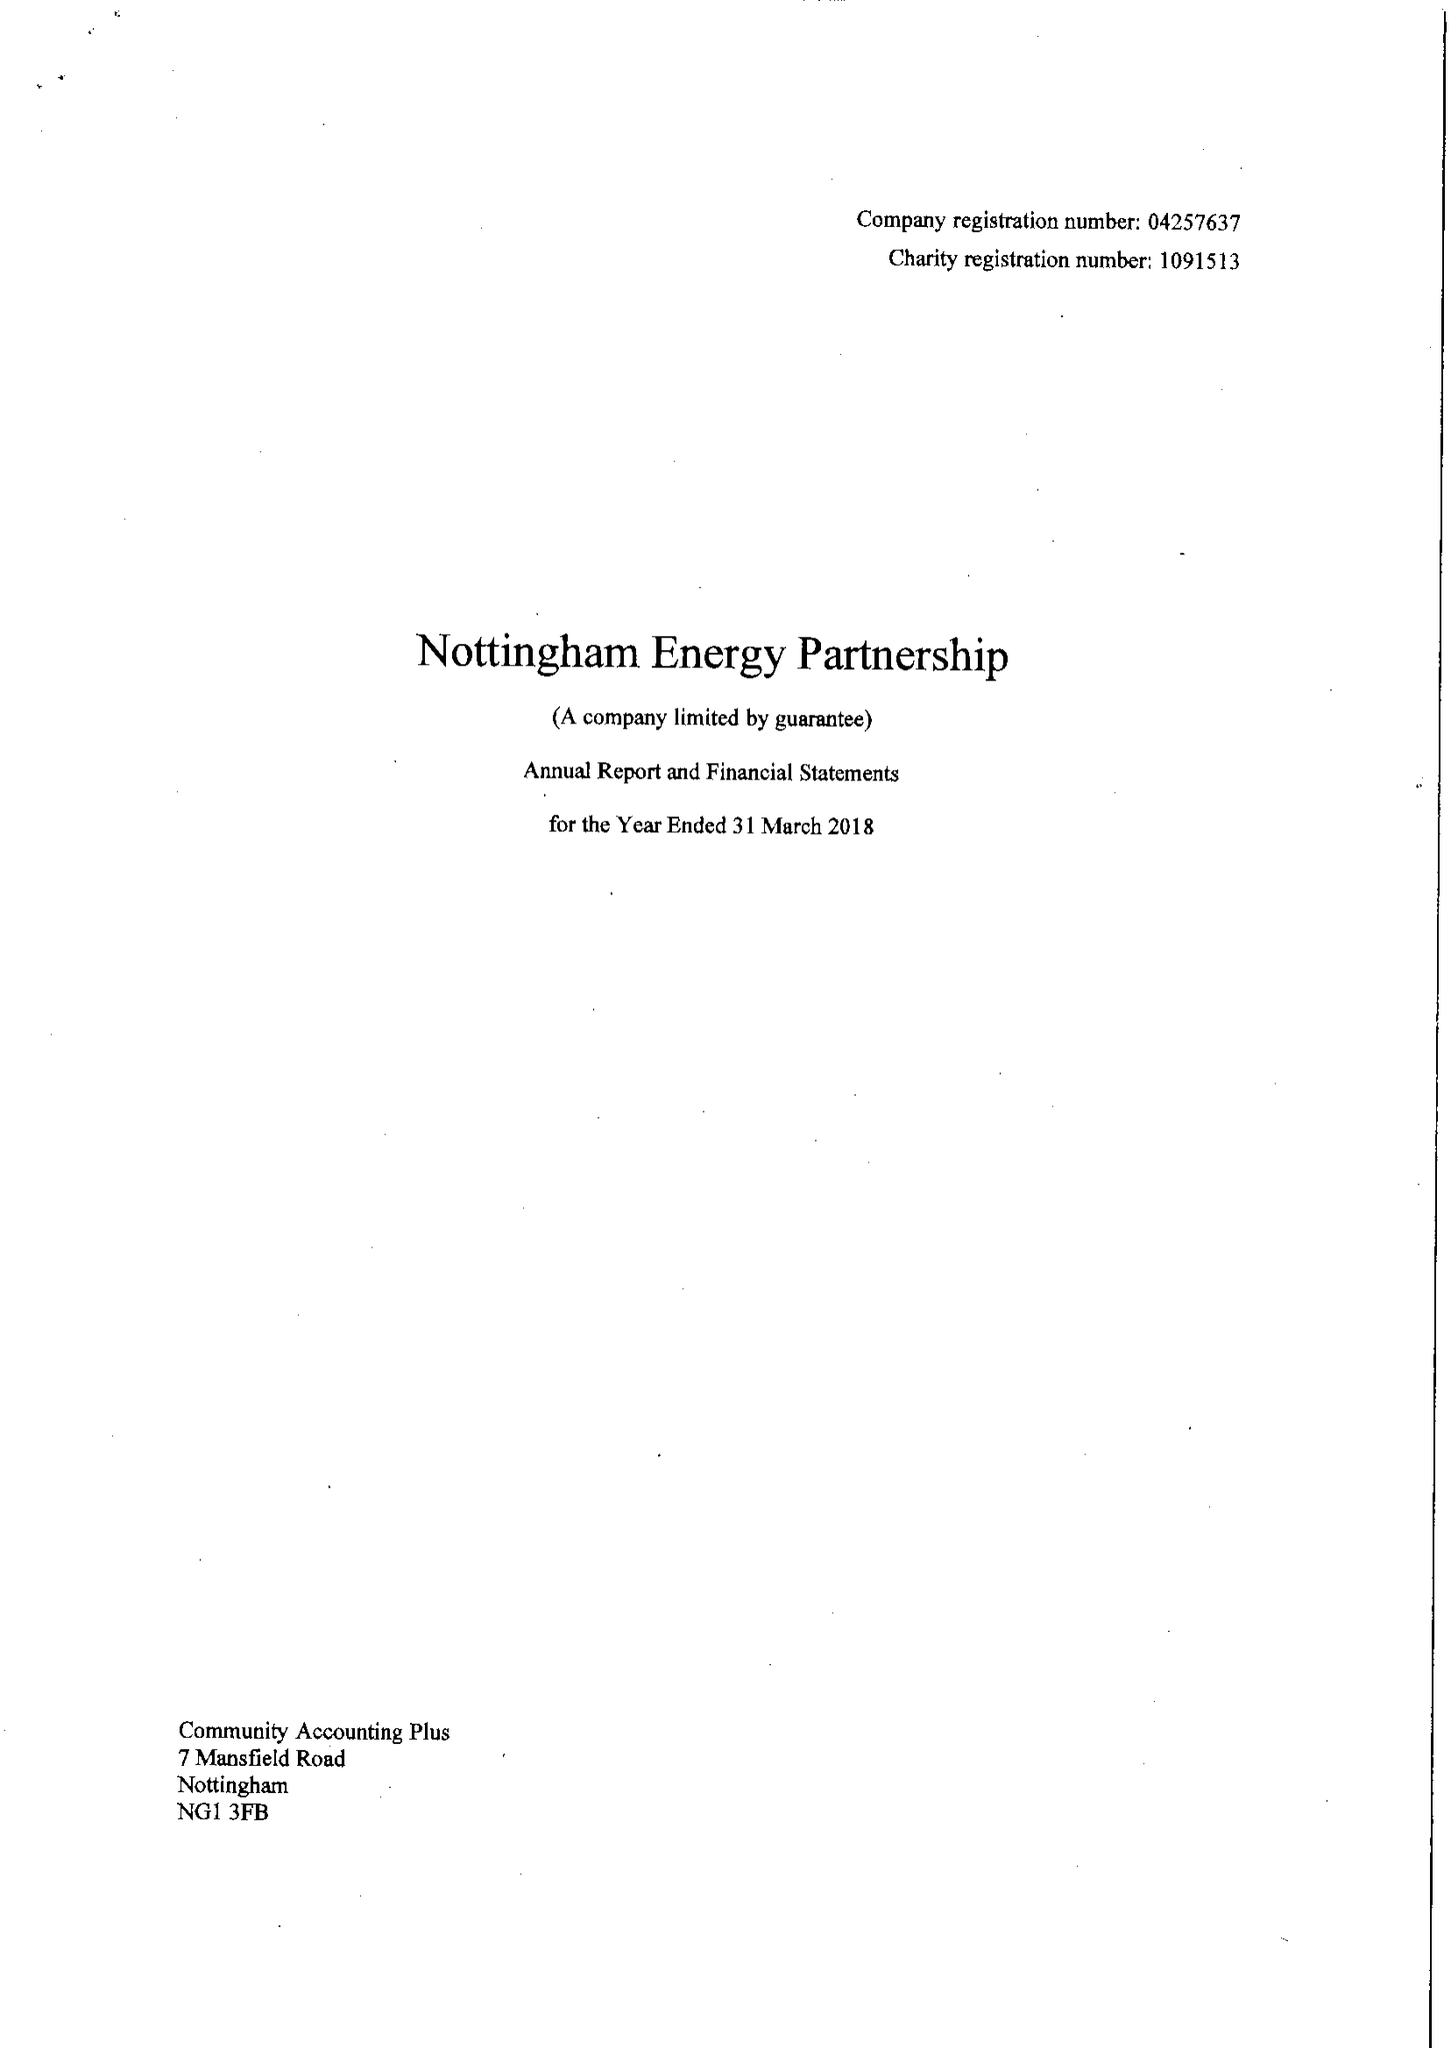What is the value for the address__street_line?
Answer the question using a single word or phrase. WATERWAY STREET 